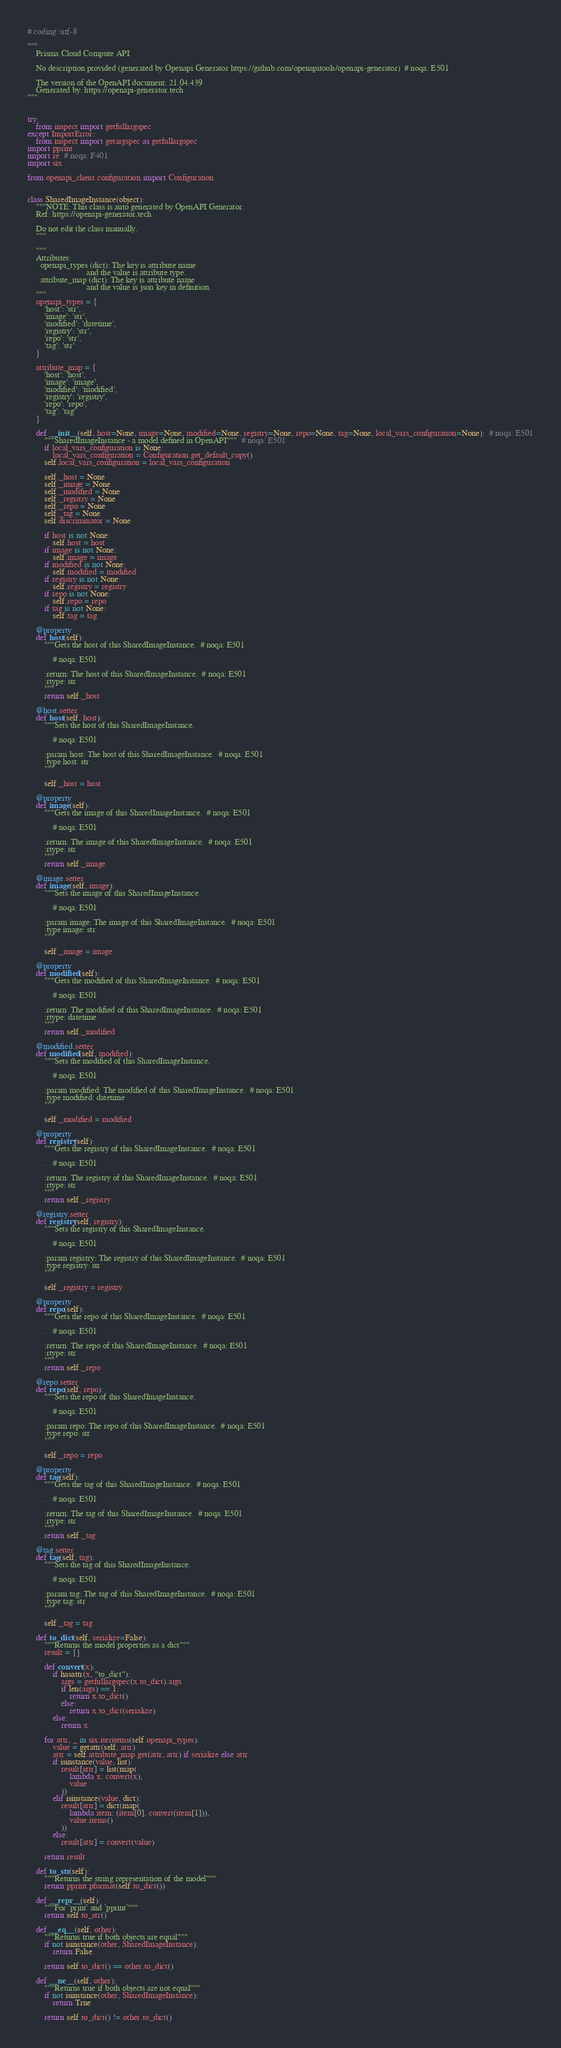Convert code to text. <code><loc_0><loc_0><loc_500><loc_500><_Python_># coding: utf-8

"""
    Prisma Cloud Compute API

    No description provided (generated by Openapi Generator https://github.com/openapitools/openapi-generator)  # noqa: E501

    The version of the OpenAPI document: 21.04.439
    Generated by: https://openapi-generator.tech
"""


try:
    from inspect import getfullargspec
except ImportError:
    from inspect import getargspec as getfullargspec
import pprint
import re  # noqa: F401
import six

from openapi_client.configuration import Configuration


class SharedImageInstance(object):
    """NOTE: This class is auto generated by OpenAPI Generator.
    Ref: https://openapi-generator.tech

    Do not edit the class manually.
    """

    """
    Attributes:
      openapi_types (dict): The key is attribute name
                            and the value is attribute type.
      attribute_map (dict): The key is attribute name
                            and the value is json key in definition.
    """
    openapi_types = {
        'host': 'str',
        'image': 'str',
        'modified': 'datetime',
        'registry': 'str',
        'repo': 'str',
        'tag': 'str'
    }

    attribute_map = {
        'host': 'host',
        'image': 'image',
        'modified': 'modified',
        'registry': 'registry',
        'repo': 'repo',
        'tag': 'tag'
    }

    def __init__(self, host=None, image=None, modified=None, registry=None, repo=None, tag=None, local_vars_configuration=None):  # noqa: E501
        """SharedImageInstance - a model defined in OpenAPI"""  # noqa: E501
        if local_vars_configuration is None:
            local_vars_configuration = Configuration.get_default_copy()
        self.local_vars_configuration = local_vars_configuration

        self._host = None
        self._image = None
        self._modified = None
        self._registry = None
        self._repo = None
        self._tag = None
        self.discriminator = None

        if host is not None:
            self.host = host
        if image is not None:
            self.image = image
        if modified is not None:
            self.modified = modified
        if registry is not None:
            self.registry = registry
        if repo is not None:
            self.repo = repo
        if tag is not None:
            self.tag = tag

    @property
    def host(self):
        """Gets the host of this SharedImageInstance.  # noqa: E501

        .   # noqa: E501

        :return: The host of this SharedImageInstance.  # noqa: E501
        :rtype: str
        """
        return self._host

    @host.setter
    def host(self, host):
        """Sets the host of this SharedImageInstance.

        .   # noqa: E501

        :param host: The host of this SharedImageInstance.  # noqa: E501
        :type host: str
        """

        self._host = host

    @property
    def image(self):
        """Gets the image of this SharedImageInstance.  # noqa: E501

        .   # noqa: E501

        :return: The image of this SharedImageInstance.  # noqa: E501
        :rtype: str
        """
        return self._image

    @image.setter
    def image(self, image):
        """Sets the image of this SharedImageInstance.

        .   # noqa: E501

        :param image: The image of this SharedImageInstance.  # noqa: E501
        :type image: str
        """

        self._image = image

    @property
    def modified(self):
        """Gets the modified of this SharedImageInstance.  # noqa: E501

        .   # noqa: E501

        :return: The modified of this SharedImageInstance.  # noqa: E501
        :rtype: datetime
        """
        return self._modified

    @modified.setter
    def modified(self, modified):
        """Sets the modified of this SharedImageInstance.

        .   # noqa: E501

        :param modified: The modified of this SharedImageInstance.  # noqa: E501
        :type modified: datetime
        """

        self._modified = modified

    @property
    def registry(self):
        """Gets the registry of this SharedImageInstance.  # noqa: E501

        .   # noqa: E501

        :return: The registry of this SharedImageInstance.  # noqa: E501
        :rtype: str
        """
        return self._registry

    @registry.setter
    def registry(self, registry):
        """Sets the registry of this SharedImageInstance.

        .   # noqa: E501

        :param registry: The registry of this SharedImageInstance.  # noqa: E501
        :type registry: str
        """

        self._registry = registry

    @property
    def repo(self):
        """Gets the repo of this SharedImageInstance.  # noqa: E501

        .   # noqa: E501

        :return: The repo of this SharedImageInstance.  # noqa: E501
        :rtype: str
        """
        return self._repo

    @repo.setter
    def repo(self, repo):
        """Sets the repo of this SharedImageInstance.

        .   # noqa: E501

        :param repo: The repo of this SharedImageInstance.  # noqa: E501
        :type repo: str
        """

        self._repo = repo

    @property
    def tag(self):
        """Gets the tag of this SharedImageInstance.  # noqa: E501

        .   # noqa: E501

        :return: The tag of this SharedImageInstance.  # noqa: E501
        :rtype: str
        """
        return self._tag

    @tag.setter
    def tag(self, tag):
        """Sets the tag of this SharedImageInstance.

        .   # noqa: E501

        :param tag: The tag of this SharedImageInstance.  # noqa: E501
        :type tag: str
        """

        self._tag = tag

    def to_dict(self, serialize=False):
        """Returns the model properties as a dict"""
        result = {}

        def convert(x):
            if hasattr(x, "to_dict"):
                args = getfullargspec(x.to_dict).args
                if len(args) == 1:
                    return x.to_dict()
                else:
                    return x.to_dict(serialize)
            else:
                return x

        for attr, _ in six.iteritems(self.openapi_types):
            value = getattr(self, attr)
            attr = self.attribute_map.get(attr, attr) if serialize else attr
            if isinstance(value, list):
                result[attr] = list(map(
                    lambda x: convert(x),
                    value
                ))
            elif isinstance(value, dict):
                result[attr] = dict(map(
                    lambda item: (item[0], convert(item[1])),
                    value.items()
                ))
            else:
                result[attr] = convert(value)

        return result

    def to_str(self):
        """Returns the string representation of the model"""
        return pprint.pformat(self.to_dict())

    def __repr__(self):
        """For `print` and `pprint`"""
        return self.to_str()

    def __eq__(self, other):
        """Returns true if both objects are equal"""
        if not isinstance(other, SharedImageInstance):
            return False

        return self.to_dict() == other.to_dict()

    def __ne__(self, other):
        """Returns true if both objects are not equal"""
        if not isinstance(other, SharedImageInstance):
            return True

        return self.to_dict() != other.to_dict()
</code> 